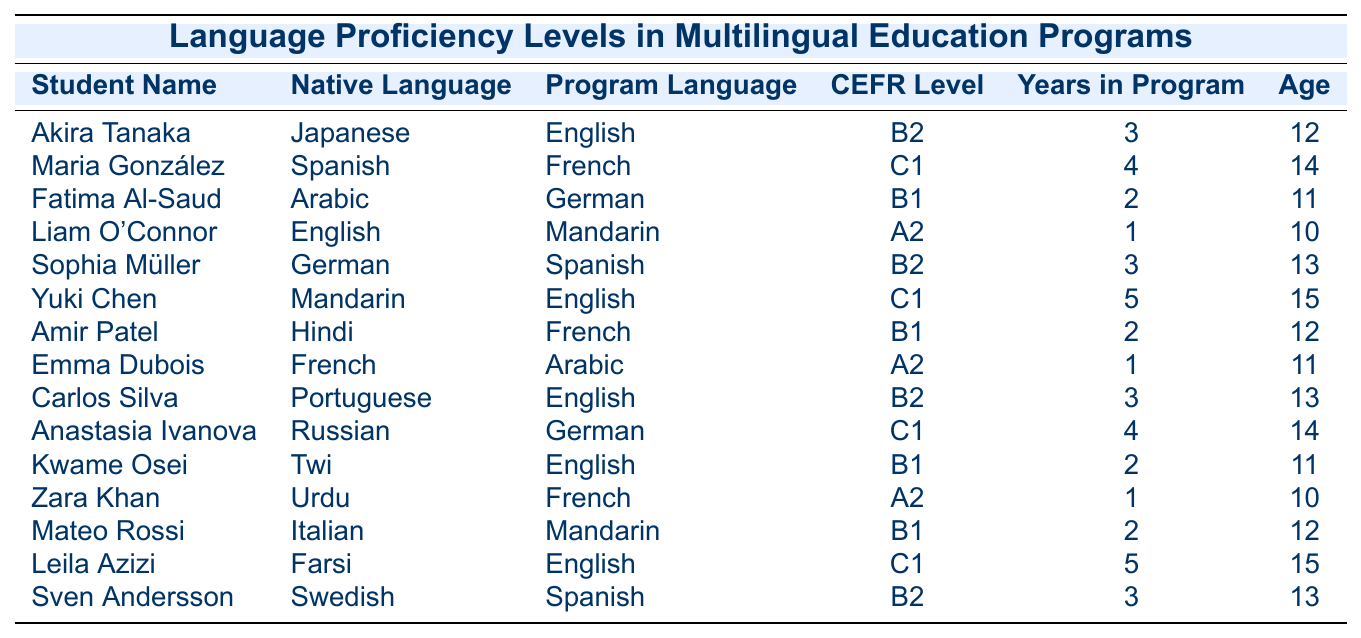What is the CEFR level of Akira Tanaka? Akira Tanaka is listed under the "CEFR Level" column with the level "B2".
Answer: B2 How many years has Yuki Chen been in the program? Yuki Chen's entry in the "Years in Program" column shows he has been in the program for 5 years.
Answer: 5 Which student has a native language of Arabic? Searching through the "Native Language" column, "Fatima Al-Saud" is the student who speaks Arabic.
Answer: Fatima Al-Saud How many students are at level C1? The table shows the names of students at level C1: Maria González, Yuki Chen, Anastasia Ivanova, and Leila Azizi. Counting these gives us a total of 4 students.
Answer: 4 What is the average age of the students in the table? Adding the ages (12 + 14 + 11 + 10 + 13 + 15 + 12 + 11 + 13 + 14 + 11 + 10 + 12 + 15 + 13) = 187, and there are 15 students, so the average age is 187/15 = 12.47, approximately 12.5.
Answer: 12.5 Is there any student who has not been in the program for at least 2 years? Scanning the "Years in Program" column reveals Liam O'Connor, Emma Dubois, and Zara Khan have only been in for 1 year; thus, it is true that there are students with less than 2 years.
Answer: Yes Which program language is most frequently studied among the students? By reviewing the "Program Language" column, "English" appears in Akira Tanaka, Yuki Chen, Carlos Silva, and Leila Azizi’s records, making it the most common language studied.
Answer: English Who is the oldest student, and what is their CEFR level? The oldest student listed is Yuki Chen, who is 15 years old. According to the table, their CEFR level in English is C1.
Answer: Yuki Chen, C1 Are there more students learning French or Spanish? Counting in the "Program Language" column, we find that French is being learned by Maria González, Amir Patel, and Zara Khan (3 students), while Spanish is being studied by Sophia Müller, Sven Andersson (2 students), thus French has more learners.
Answer: More students study French What is the median age of the students? First, we need to arrange the students' ages (10, 10, 11, 11, 11, 12, 12, 12, 13, 13, 13, 14, 14, 15, 15). The middle two numbers are both 12, so the median age is (12 + 12) / 2 = 12.
Answer: 12 